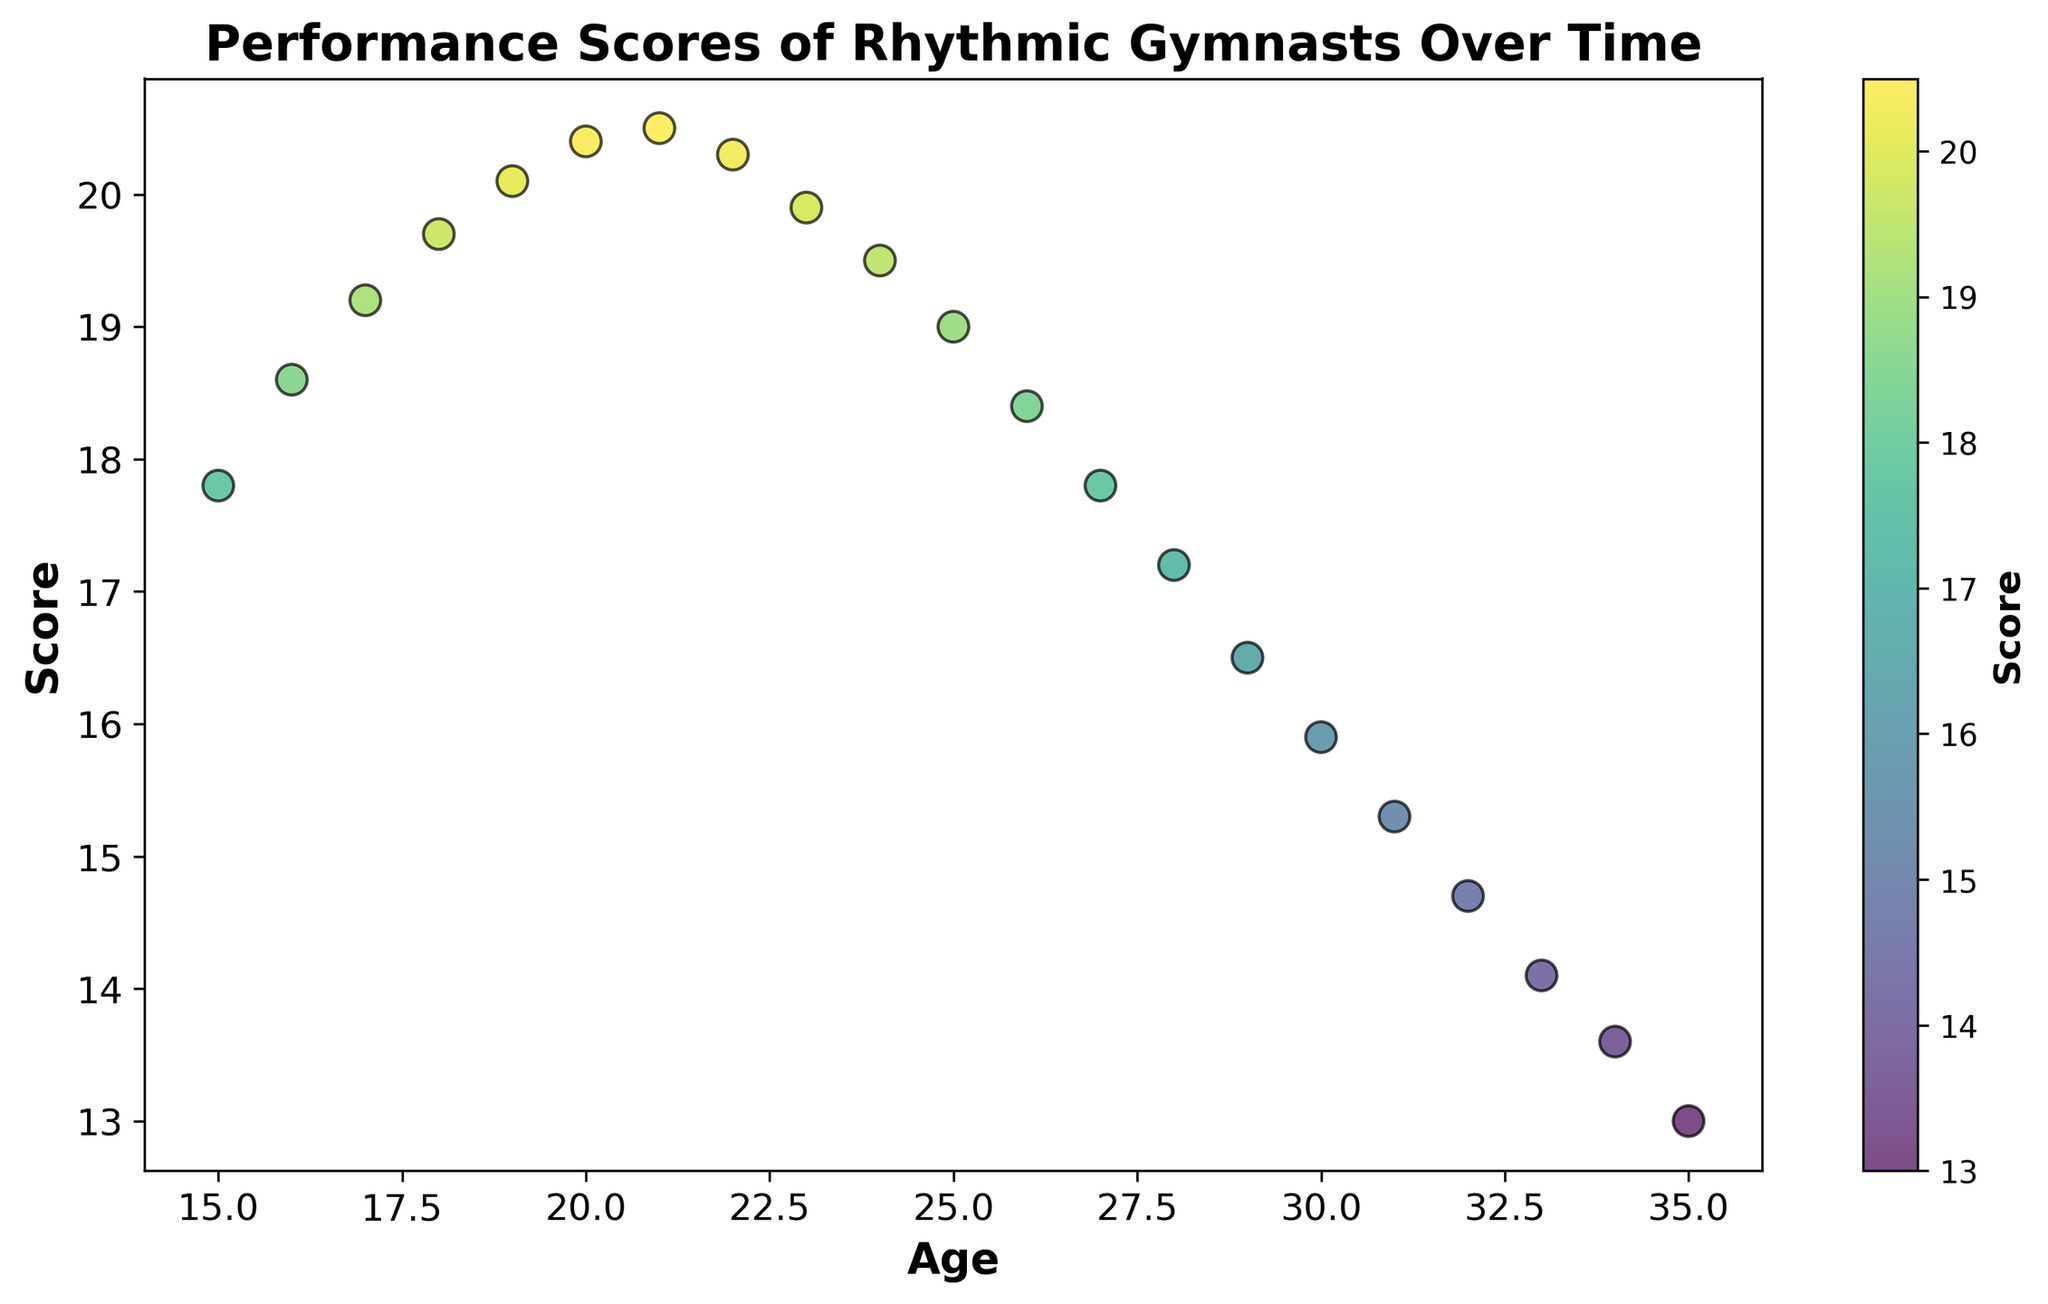What is the highest performance score recorded and at what age? The highest performance score recorded in the scatter plot is 20.5, which can be seen at the age of 21.
Answer: 20.5 at age 21 How does the performance score change as gymnasts age from 15 to 35 years old? By examining the scatter plot, we can see that performance scores generally increase from age 15 (17.8) to age 21 (20.5) and then gradually decline until age 35 (13.0).
Answer: Increases till 21, then decreases Is there a significant drop in performance score at any particular age? If so, when? By visually inspecting the scatter plot, we see a significant drop in performance score after age 21; compared to the gradual decline, ages 23 to 24 show noticeable drops from 20.3 to 19.5.
Answer: Around age 23 to 24 What is the difference in performance scores between the ages of 20 and 30? At age 20, the score is 20.4, and at age 30, the score is 15.9. The difference between these scores is 20.4 - 15.9 = 4.5.
Answer: 4.5 Which age group shows the steepest decline in performance scores? By looking at the slope of the data points on the scatter plot, the steepest decline is observed between the ages of 31 (15.3) and 32 (14.7), where the performance drops significantly by 0.6 points.
Answer: Age 31 to 32 How do the colors of the scatter points change with the performance scores? The scatter points are colored using a viridis colormap, which transitions from dark blue for the lowest scores to yellow for the highest scores. As the performance score increases, the color transitions from blue to green to yellow.
Answer: Blue to yellow as score increases What is the average performance score for the age range 25 to 30? To calculate the average performance score for ages 25 to 30, sum the scores: (19 + 18.4 + 17.8 + 17.2 + 16.5 + 15.9) = 104.8, and then divide by the number of ages (6): 104.8 / 6 = 17.4667.
Answer: 17.47 For which age range is the performance score relatively stable, showing minimal changes? By examining the scatter plot, ages 20 to 22 show relatively stable performance scores with small variations (20.4, 20.5, 20.3).
Answer: Ages 20-22 Which age has the most visually prominent (brightest) color, signifying the highest performance score? The age 21 has the most visually prominent color with the brightest, yellow hue, signifying the highest performance score of 20.5.
Answer: Age 21 